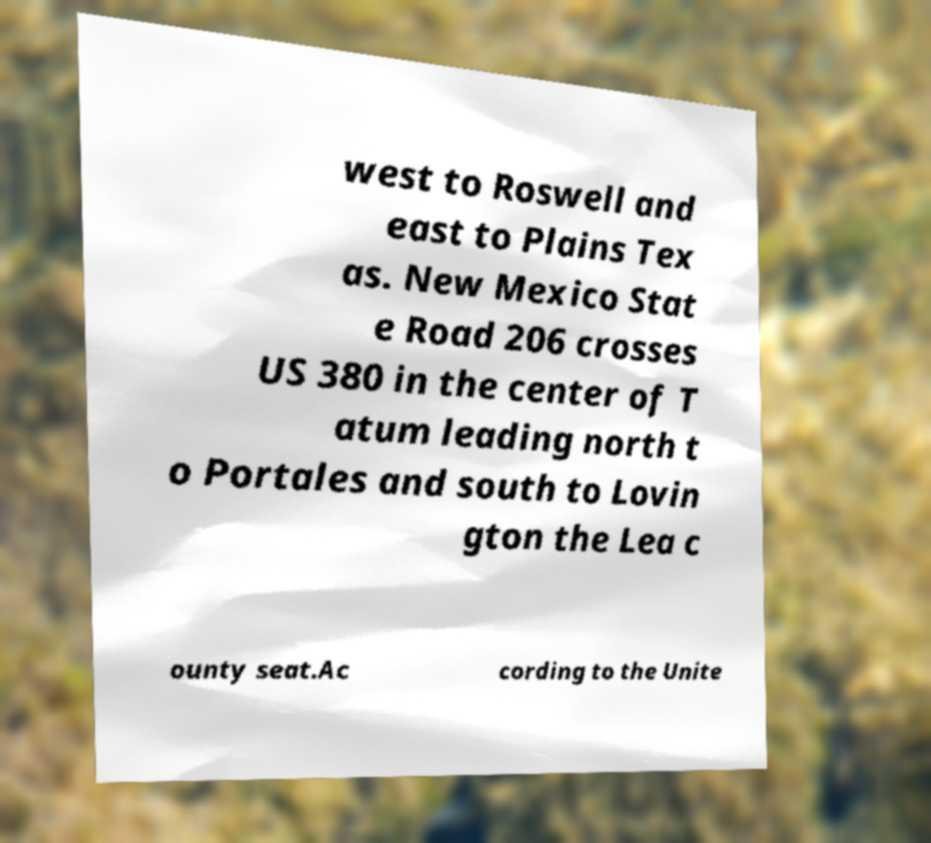Could you assist in decoding the text presented in this image and type it out clearly? west to Roswell and east to Plains Tex as. New Mexico Stat e Road 206 crosses US 380 in the center of T atum leading north t o Portales and south to Lovin gton the Lea c ounty seat.Ac cording to the Unite 